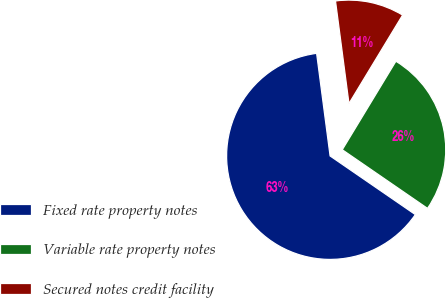Convert chart. <chart><loc_0><loc_0><loc_500><loc_500><pie_chart><fcel>Fixed rate property notes<fcel>Variable rate property notes<fcel>Secured notes credit facility<nl><fcel>63.33%<fcel>25.92%<fcel>10.75%<nl></chart> 